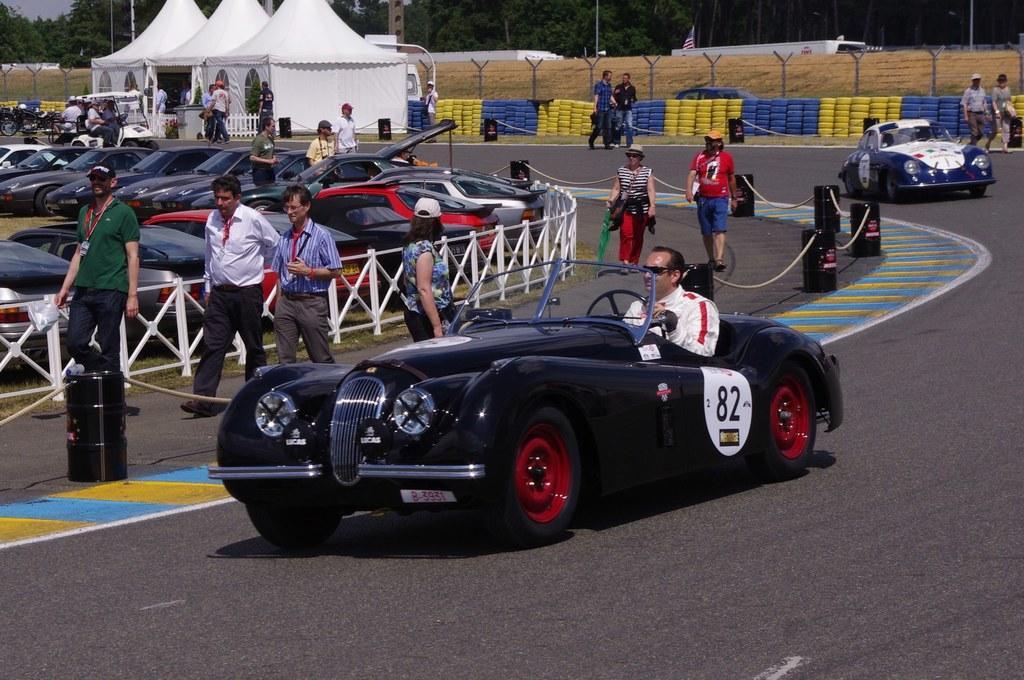Describe this image in one or two sentences. In this picture I can see group of people standing, there are vehicles, there are rope barriers, tyres, there is fence, there are canopy tents, and in the background there is the sky. 